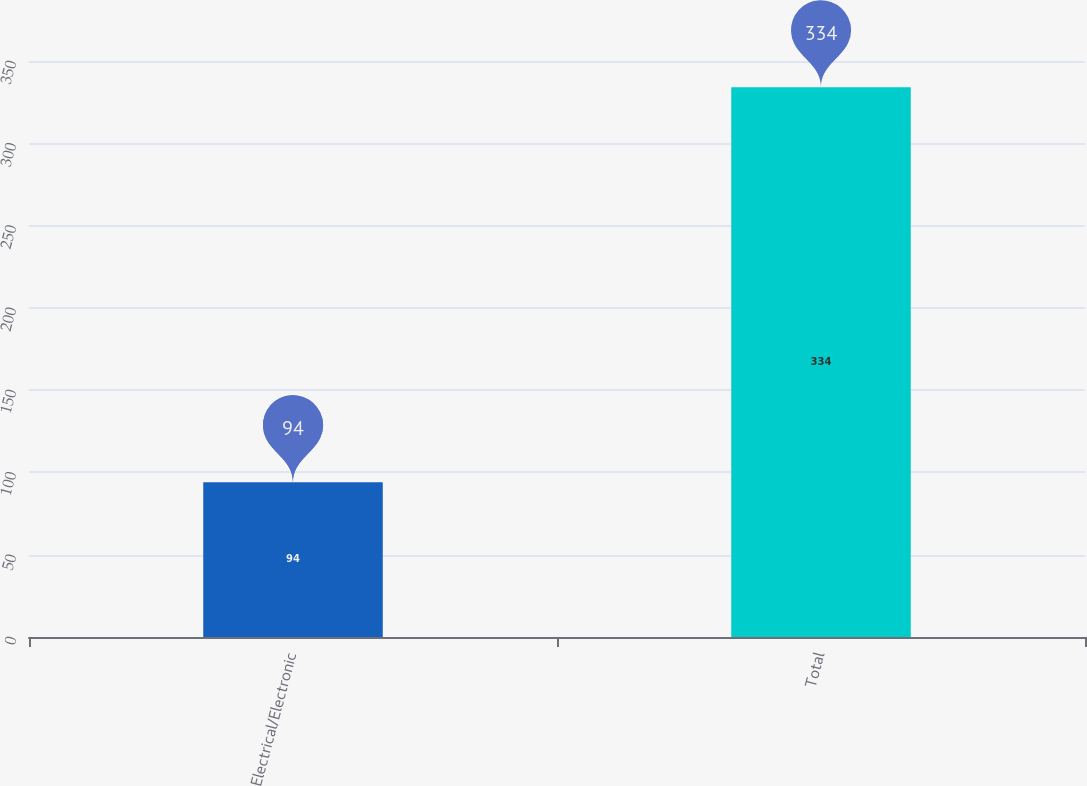<chart> <loc_0><loc_0><loc_500><loc_500><bar_chart><fcel>Electrical/Electronic<fcel>Total<nl><fcel>94<fcel>334<nl></chart> 